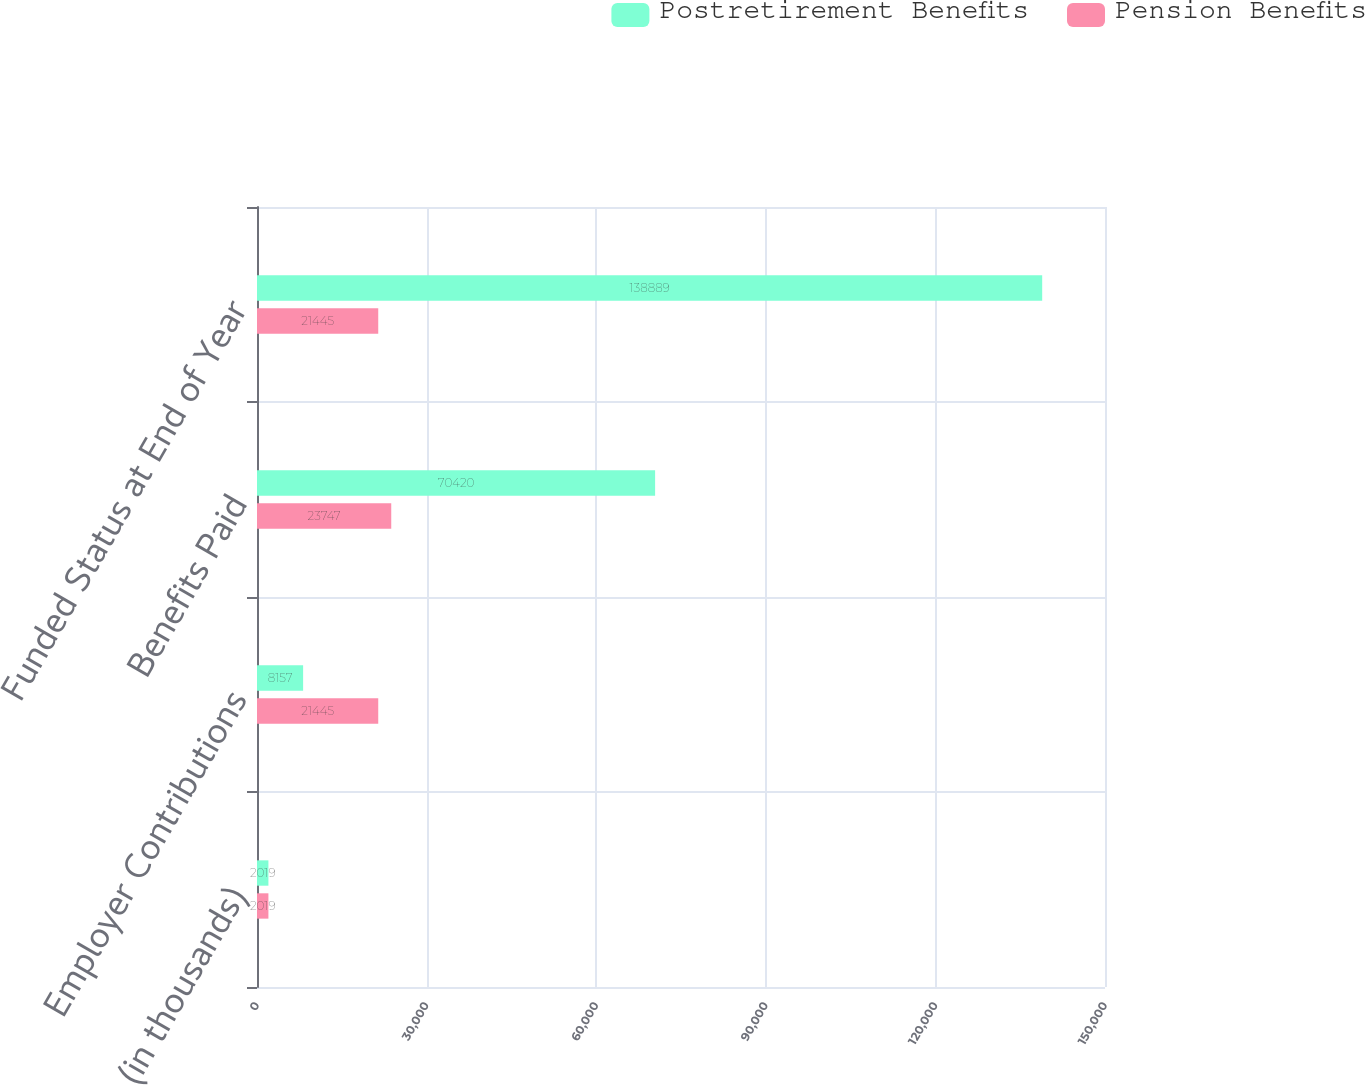<chart> <loc_0><loc_0><loc_500><loc_500><stacked_bar_chart><ecel><fcel>(in thousands)<fcel>Employer Contributions<fcel>Benefits Paid<fcel>Funded Status at End of Year<nl><fcel>Postretirement Benefits<fcel>2019<fcel>8157<fcel>70420<fcel>138889<nl><fcel>Pension Benefits<fcel>2019<fcel>21445<fcel>23747<fcel>21445<nl></chart> 